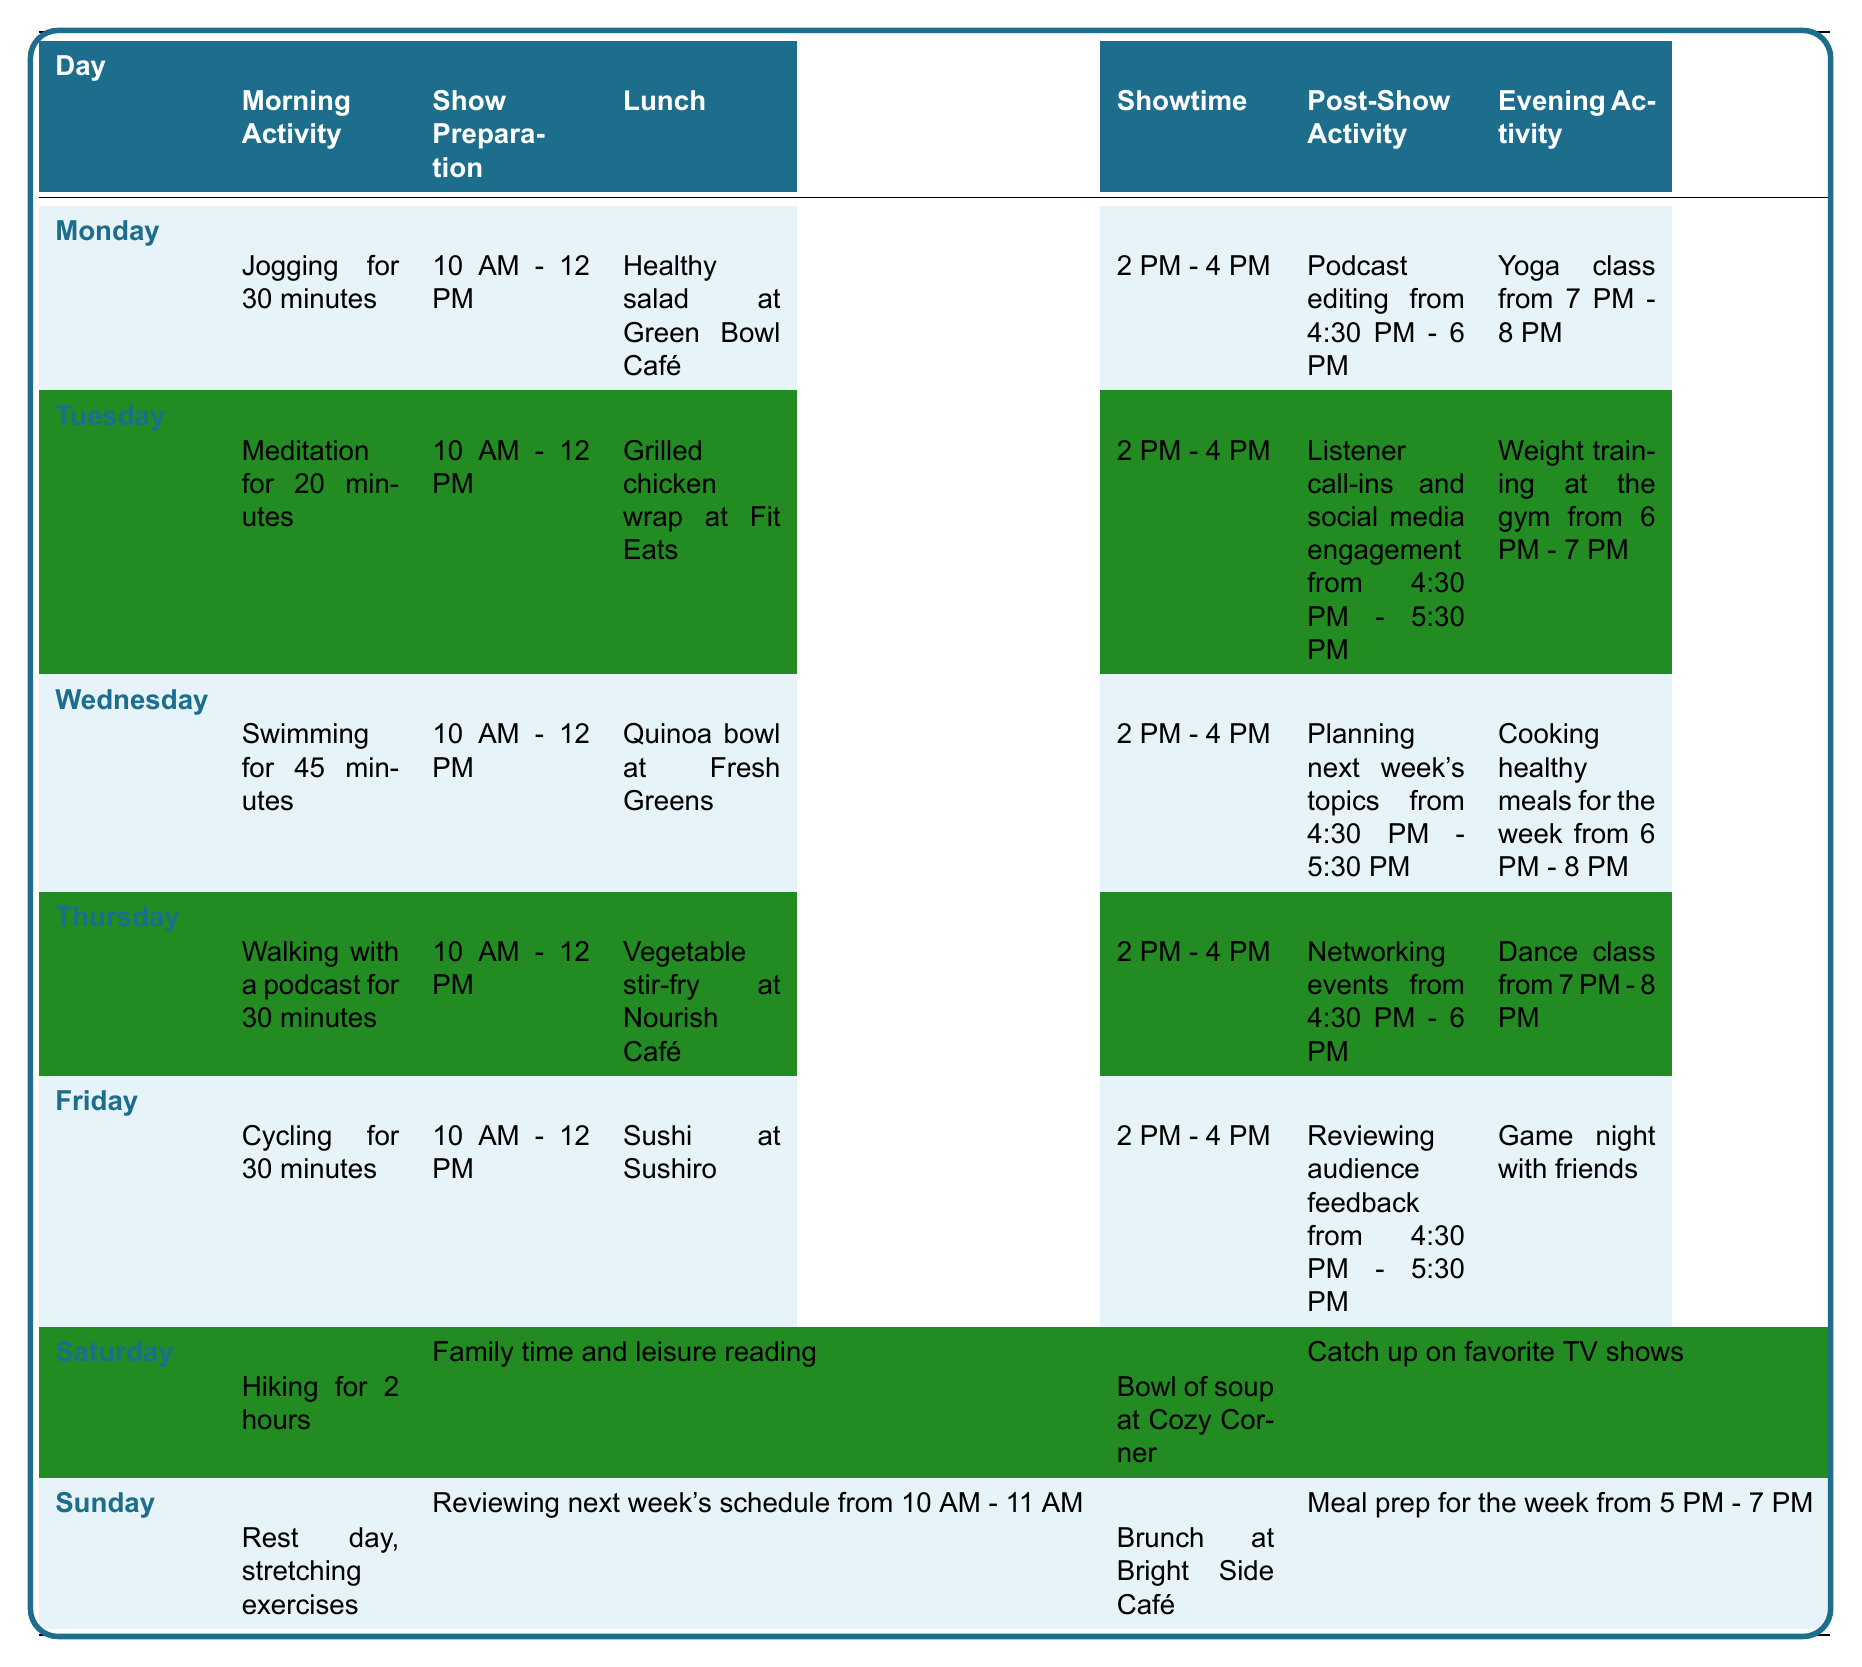What is the morning activity on Friday? In the table, Friday's morning activity is listed as "Cycling for 30 minutes."
Answer: Cycling for 30 minutes Which day includes a yoga class in the evening? Referring to the table, Monday has an evening activity listed as "Yoga class from 7 PM - 8 PM."
Answer: Monday On which days does the radio talk show host have session preparation scheduled? Each day from Monday to Thursday has a "Show Preparation" time listed from "10 AM - 12 PM." Thus, the preparation occurs on these four days: Monday, Tuesday, Wednesday, and Thursday.
Answer: Monday, Tuesday, Wednesday, Thursday What is the total duration of exercise on Saturday? On Saturday, the morning activity is "Hiking for 2 hours," and there are no additional exercise activities listed. Therefore, the total duration of exercise is 2 hours.
Answer: 2 hours How many different types of lunch are there throughout the week? The lunches listed are: Healthy salad, Grilled chicken wrap, Quinoa bowl, Vegetable stir-fry, Sushi, Bowl of soup, and Brunch. This results in 7 different types of lunch across the week.
Answer: 7 Is there any day when the host has a rest day? According to the table, Sunday is marked as a "Rest day, stretching exercises," which qualifies it as a rest day.
Answer: Yes What activity is scheduled immediately after the show on Wednesday? The post-show activity on Wednesday, as per the table, is "Planning next week's topics from 4:30 PM - 5:30 PM."
Answer: Planning next week's topics Which evening activity is the longest in duration during the week? Monday's evening activity, "Yoga class from 7 PM - 8 PM," lasts for 1 hour. Similarly, Saturday's activity, "Catch up on favorite TV shows," doesn't specify the duration. However, since it likely varies, Monday's yoga class is one of the longest specified. Saturdays' "Family time and leisure reading" may also be longer but is not quantified. Thus, based on the provided data, Monday's yoga class can be considered the longest listed.
Answer: Yoga class from 7 PM - 8 PM How many days contain weight lifting or training activities? The only day that includes weight training is Tuesday, where it is specified as "Weight training at the gym from 6 PM - 7 PM." Therefore, it occurs on just one day.
Answer: 1 What is the average length of morning activities during the week? The morning activities are: Jogging (30 min), Meditation (20 min), Swimming (45 min), Walking (30 min), Cycling (30 min), Hiking (120 min), and Rest day (0 min). The total duration sums to 305 minutes (30 + 20 + 45 + 30 + 30 + 120 + 0). Dividing by 7 (the number of days), the average length is approximately 43.57, which we can round to about 44 minutes.
Answer: 44 minutes 